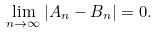<formula> <loc_0><loc_0><loc_500><loc_500>\lim _ { n \rightarrow \infty } | A _ { n } - B _ { n } | = 0 .</formula> 